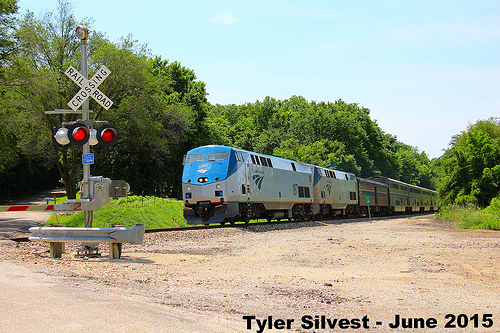<image>
Can you confirm if the traffic sign is behind the train? No. The traffic sign is not behind the train. From this viewpoint, the traffic sign appears to be positioned elsewhere in the scene. 